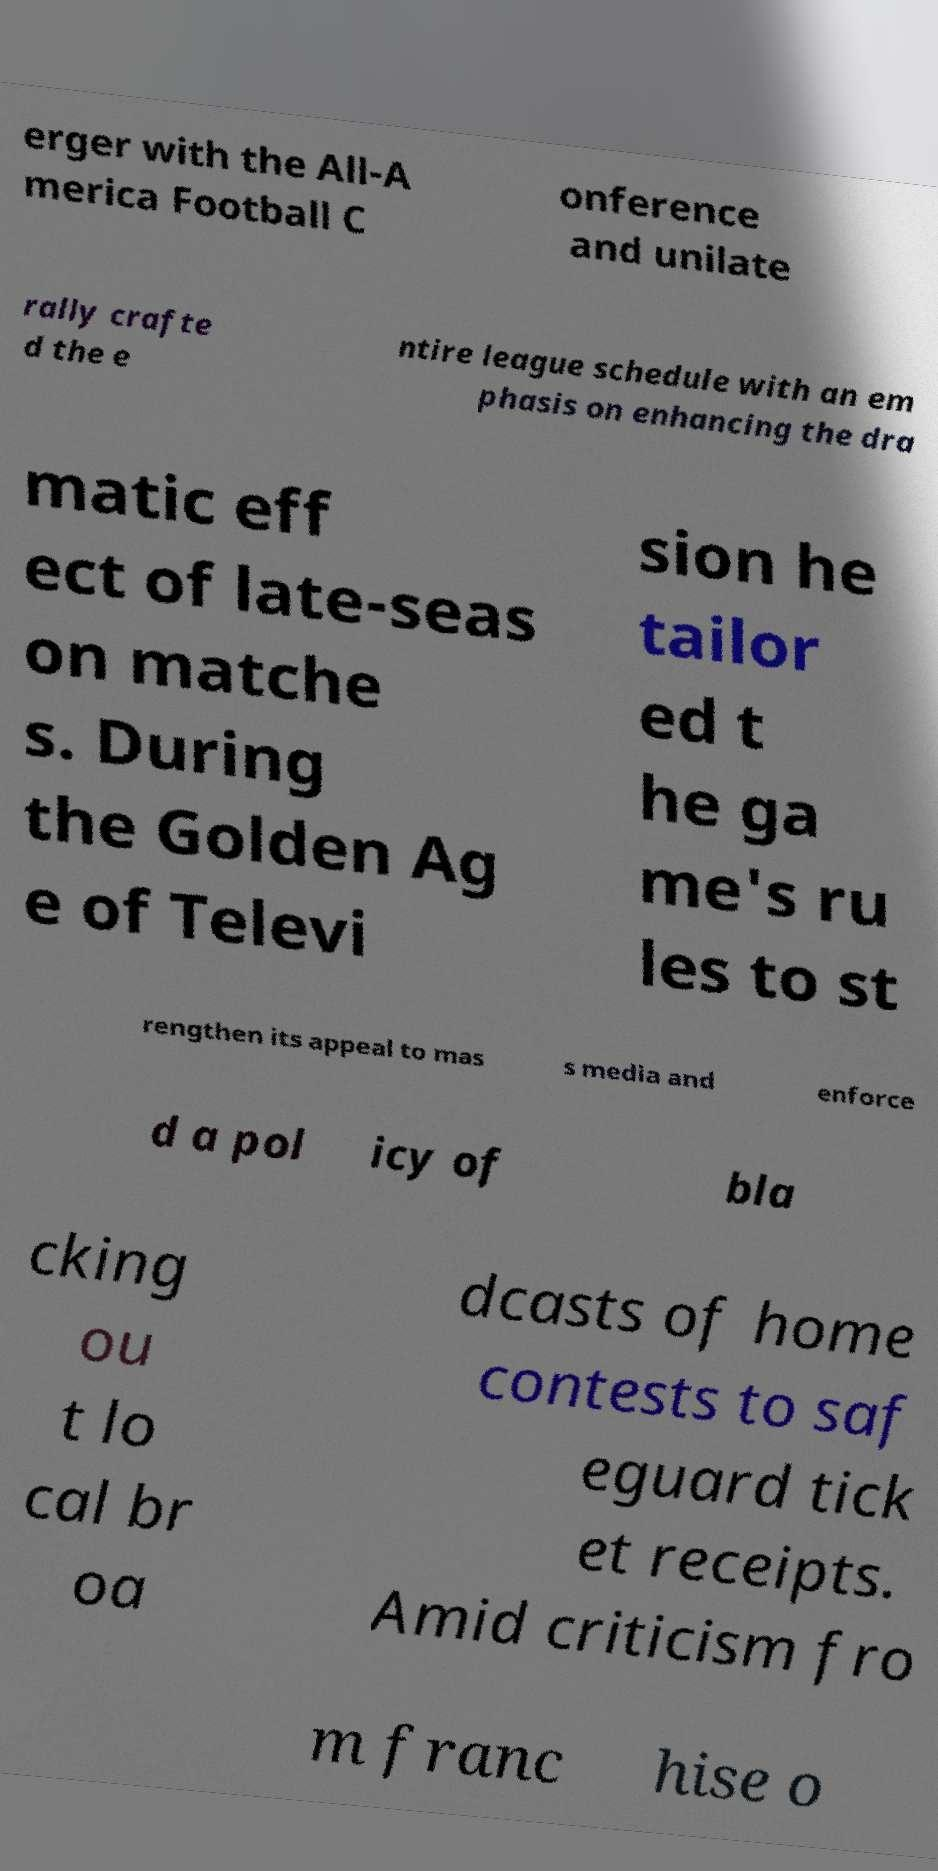Could you assist in decoding the text presented in this image and type it out clearly? erger with the All-A merica Football C onference and unilate rally crafte d the e ntire league schedule with an em phasis on enhancing the dra matic eff ect of late-seas on matche s. During the Golden Ag e of Televi sion he tailor ed t he ga me's ru les to st rengthen its appeal to mas s media and enforce d a pol icy of bla cking ou t lo cal br oa dcasts of home contests to saf eguard tick et receipts. Amid criticism fro m franc hise o 